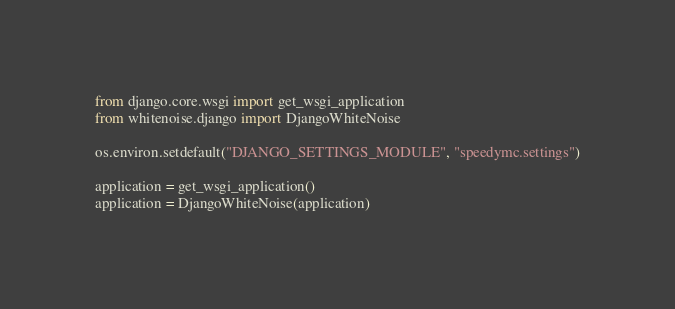Convert code to text. <code><loc_0><loc_0><loc_500><loc_500><_Python_>
from django.core.wsgi import get_wsgi_application
from whitenoise.django import DjangoWhiteNoise

os.environ.setdefault("DJANGO_SETTINGS_MODULE", "speedymc.settings")

application = get_wsgi_application()
application = DjangoWhiteNoise(application)
</code> 